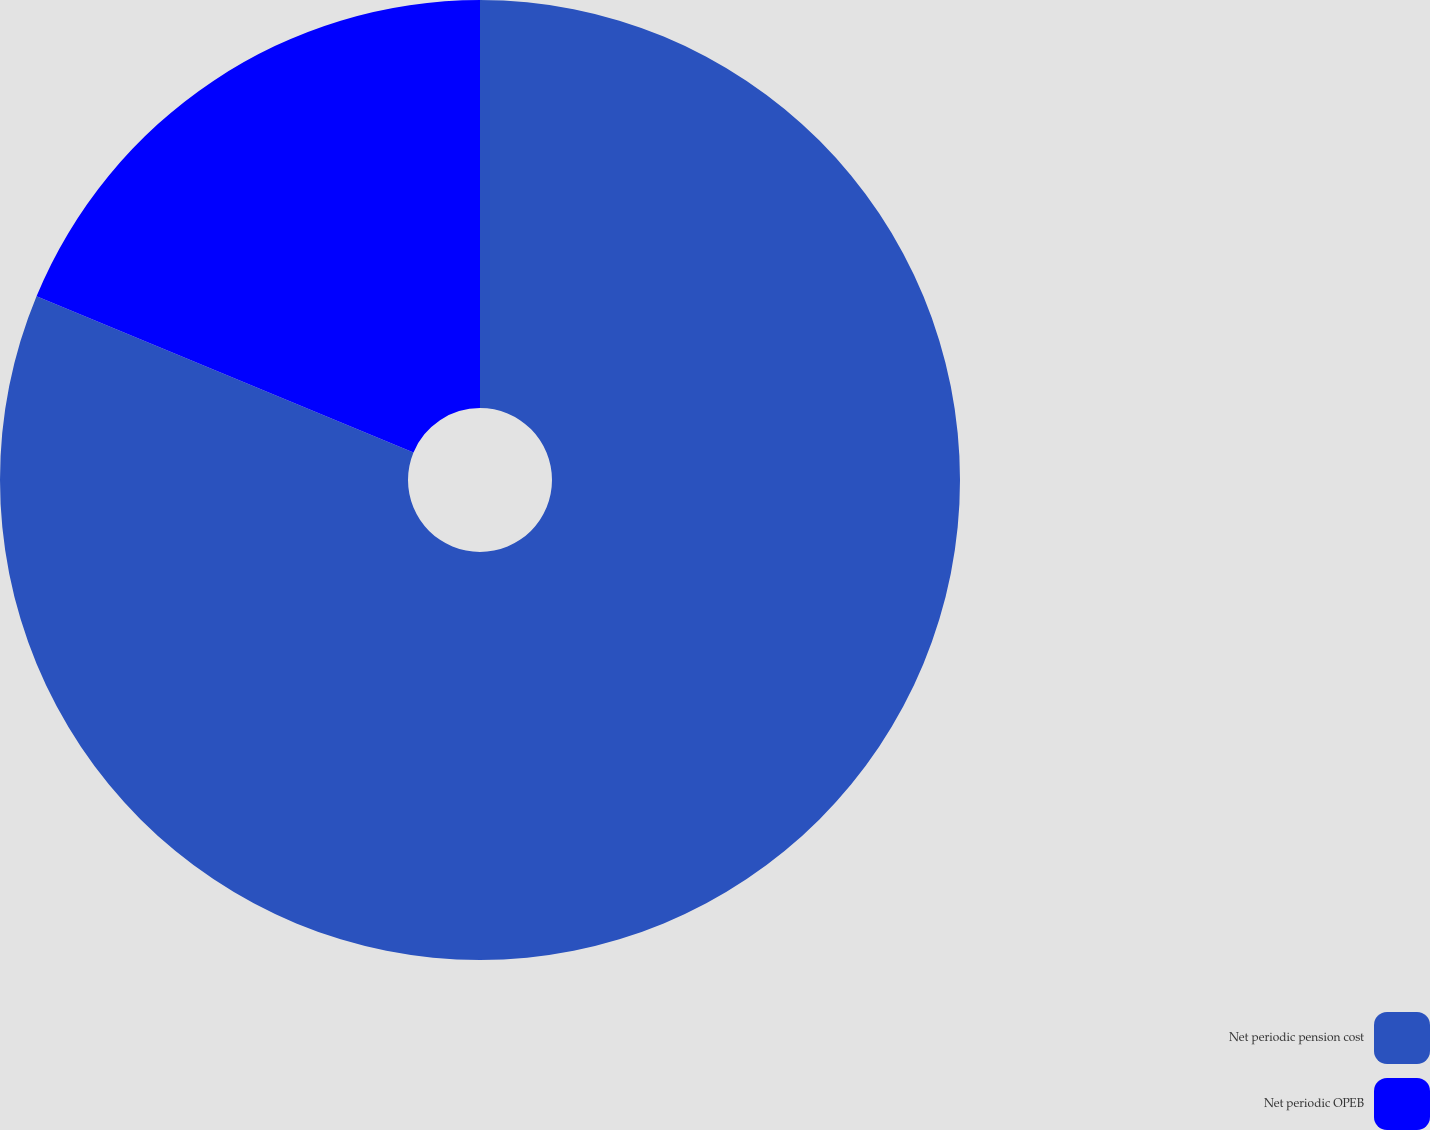<chart> <loc_0><loc_0><loc_500><loc_500><pie_chart><fcel>Net periodic pension cost<fcel>Net periodic OPEB<nl><fcel>81.25%<fcel>18.75%<nl></chart> 